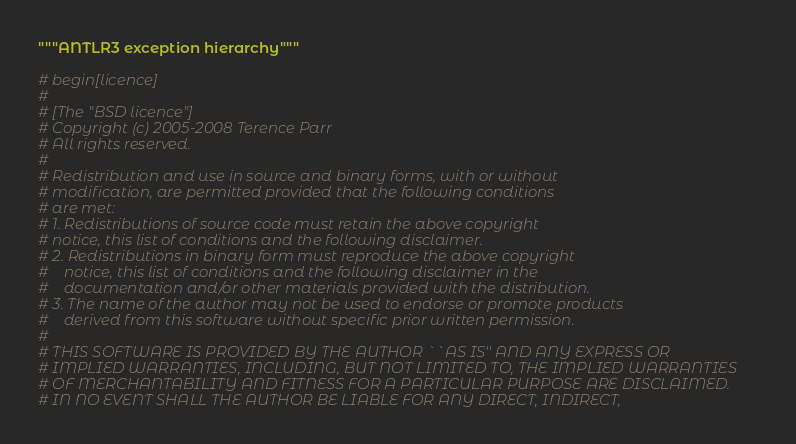<code> <loc_0><loc_0><loc_500><loc_500><_Python_>"""ANTLR3 exception hierarchy"""

# begin[licence]
#
# [The "BSD licence"]
# Copyright (c) 2005-2008 Terence Parr
# All rights reserved.
#
# Redistribution and use in source and binary forms, with or without
# modification, are permitted provided that the following conditions
# are met:
# 1. Redistributions of source code must retain the above copyright
# notice, this list of conditions and the following disclaimer.
# 2. Redistributions in binary form must reproduce the above copyright
#    notice, this list of conditions and the following disclaimer in the
#    documentation and/or other materials provided with the distribution.
# 3. The name of the author may not be used to endorse or promote products
#    derived from this software without specific prior written permission.
#
# THIS SOFTWARE IS PROVIDED BY THE AUTHOR ``AS IS'' AND ANY EXPRESS OR
# IMPLIED WARRANTIES, INCLUDING, BUT NOT LIMITED TO, THE IMPLIED WARRANTIES
# OF MERCHANTABILITY AND FITNESS FOR A PARTICULAR PURPOSE ARE DISCLAIMED.
# IN NO EVENT SHALL THE AUTHOR BE LIABLE FOR ANY DIRECT, INDIRECT,</code> 